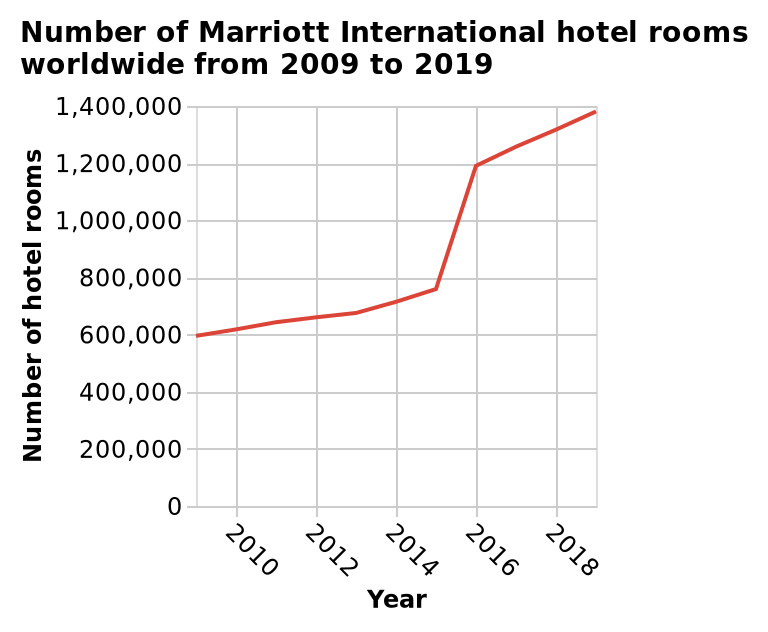<image>
How much did the number of hotel rooms change from 2015 to 2016? The number of hotel rooms nearly doubled from 2015 to 2016. Is the increase in the number of hotel rooms consistent every year? The information does not specify if the increase in the number of hotel rooms is consistent every year. What is the trend of the line graph based on the figure? The trend of the line graph represents the number of Marriott International hotel rooms worldwide from 2009 to 2019. What is the minimum number of hotel rooms shown on the y-axis? The minimum number of hotel rooms shown on the y-axis is 0. What is the range of years represented on the x-axis? The range of years represented on the x-axis is from 2009 to 2019. Did the number of hotel rooms nearly triple from 2015 to 2016? No.The number of hotel rooms nearly doubled from 2015 to 2016. 